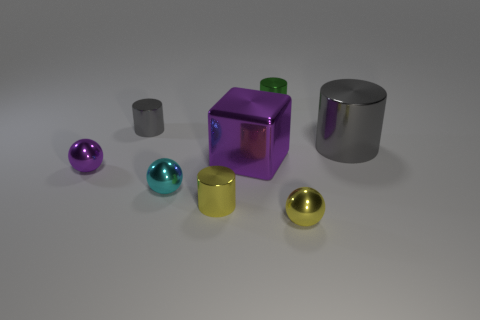What shape is the tiny yellow shiny thing that is right of the tiny cylinder in front of the big gray metal cylinder that is right of the tiny gray object?
Your answer should be compact. Sphere. What number of purple metal cubes are on the left side of the tiny cylinder in front of the big gray metal object?
Your answer should be compact. 0. There is a thing that is to the left of the tiny gray shiny cylinder; is its shape the same as the yellow metallic thing to the right of the big block?
Make the answer very short. Yes. There is a large purple shiny cube; how many purple metal things are left of it?
Make the answer very short. 1. Do the cylinder in front of the purple metallic sphere and the small purple ball have the same material?
Keep it short and to the point. Yes. What is the color of the other large thing that is the same shape as the green object?
Provide a short and direct response. Gray. What is the shape of the green object?
Your answer should be compact. Cylinder. What number of objects are either tiny purple metallic objects or shiny balls?
Make the answer very short. 3. There is a tiny metal sphere that is to the right of the small green metallic thing; is it the same color as the small metallic cylinder in front of the small gray metallic thing?
Your answer should be very brief. Yes. How many other things are the same shape as the small purple object?
Provide a succinct answer. 2. 